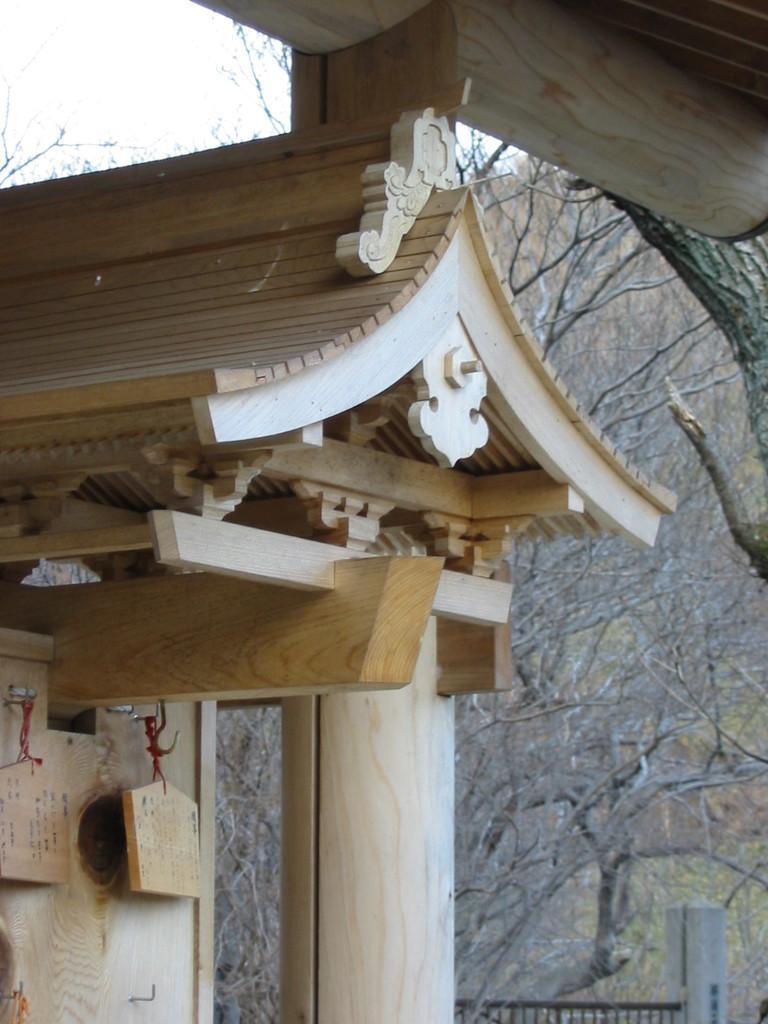How would you summarize this image in a sentence or two? In this image I can see, there is a wooden pole and construction. On the left side there are wooden planks that are hanged with the thread at the back side there are trees in this image. 